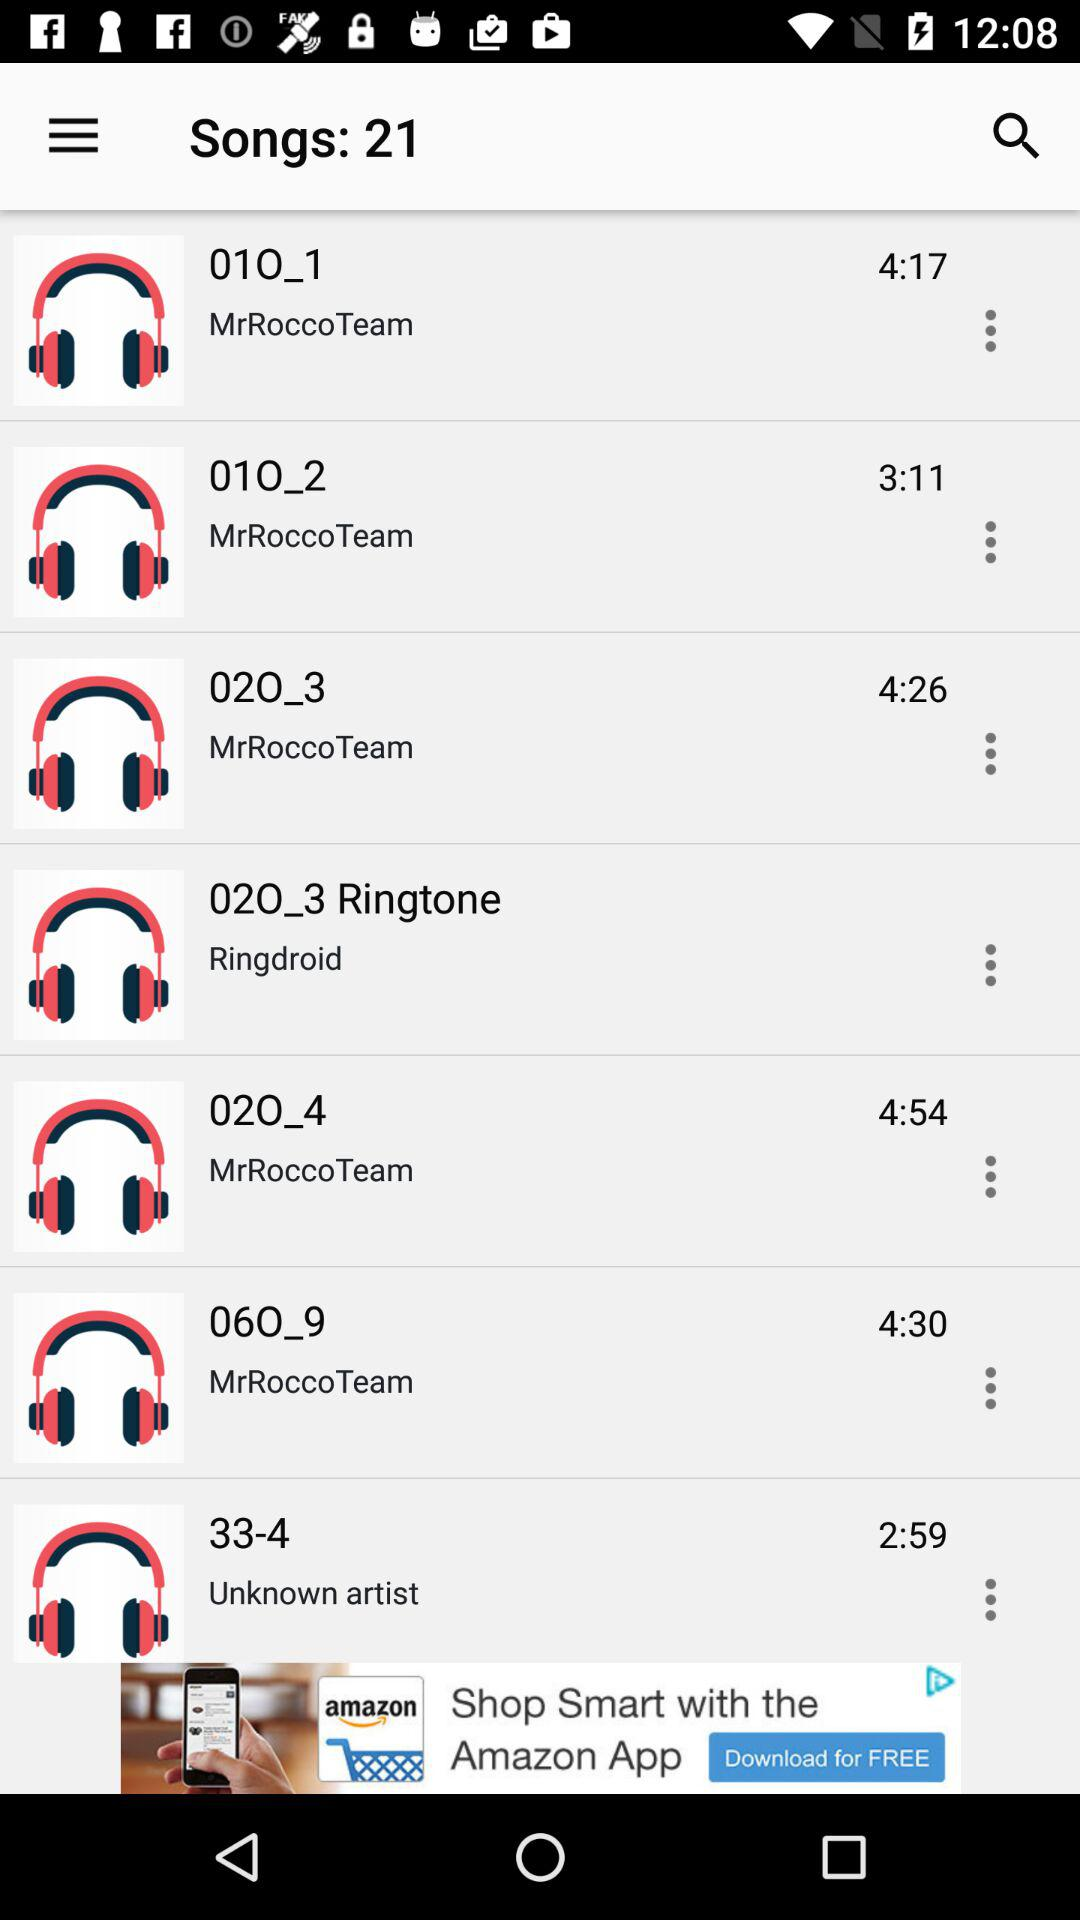What is the duration of "06O_9"? The duration of "06O_9" is 4 minutes and 30 seconds. 